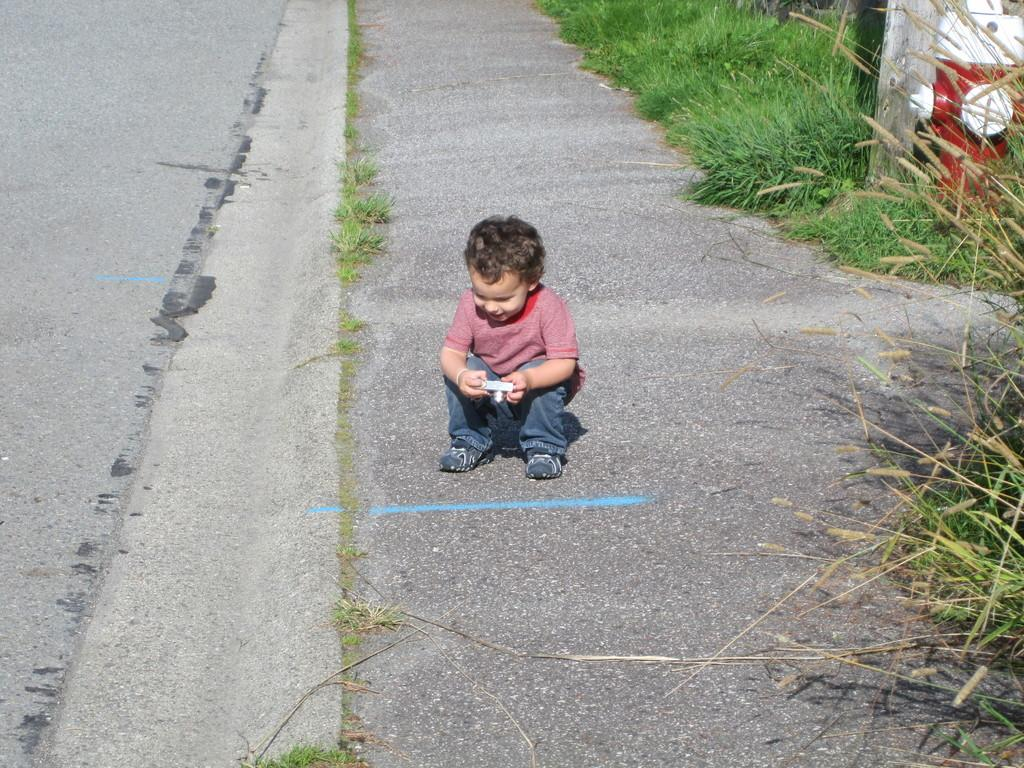What is the main subject of the image? There is a child in the image. Where is the child located? The child is on the road. What is the child wearing? The child is wearing a red top and jeans. What can be seen in the background of the image? There is green color grass in the background. What other object is visible in the image? There is a red and white color fire hydrant in the image. What type of waste is being sorted by the child in the image? There is no waste or sorting activity depicted in the image; it features a child on the road wearing a red top and jeans, with a red and white fire hydrant in the background. 